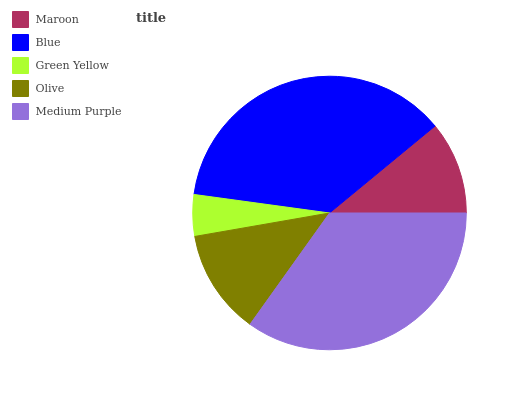Is Green Yellow the minimum?
Answer yes or no. Yes. Is Blue the maximum?
Answer yes or no. Yes. Is Blue the minimum?
Answer yes or no. No. Is Green Yellow the maximum?
Answer yes or no. No. Is Blue greater than Green Yellow?
Answer yes or no. Yes. Is Green Yellow less than Blue?
Answer yes or no. Yes. Is Green Yellow greater than Blue?
Answer yes or no. No. Is Blue less than Green Yellow?
Answer yes or no. No. Is Olive the high median?
Answer yes or no. Yes. Is Olive the low median?
Answer yes or no. Yes. Is Green Yellow the high median?
Answer yes or no. No. Is Maroon the low median?
Answer yes or no. No. 